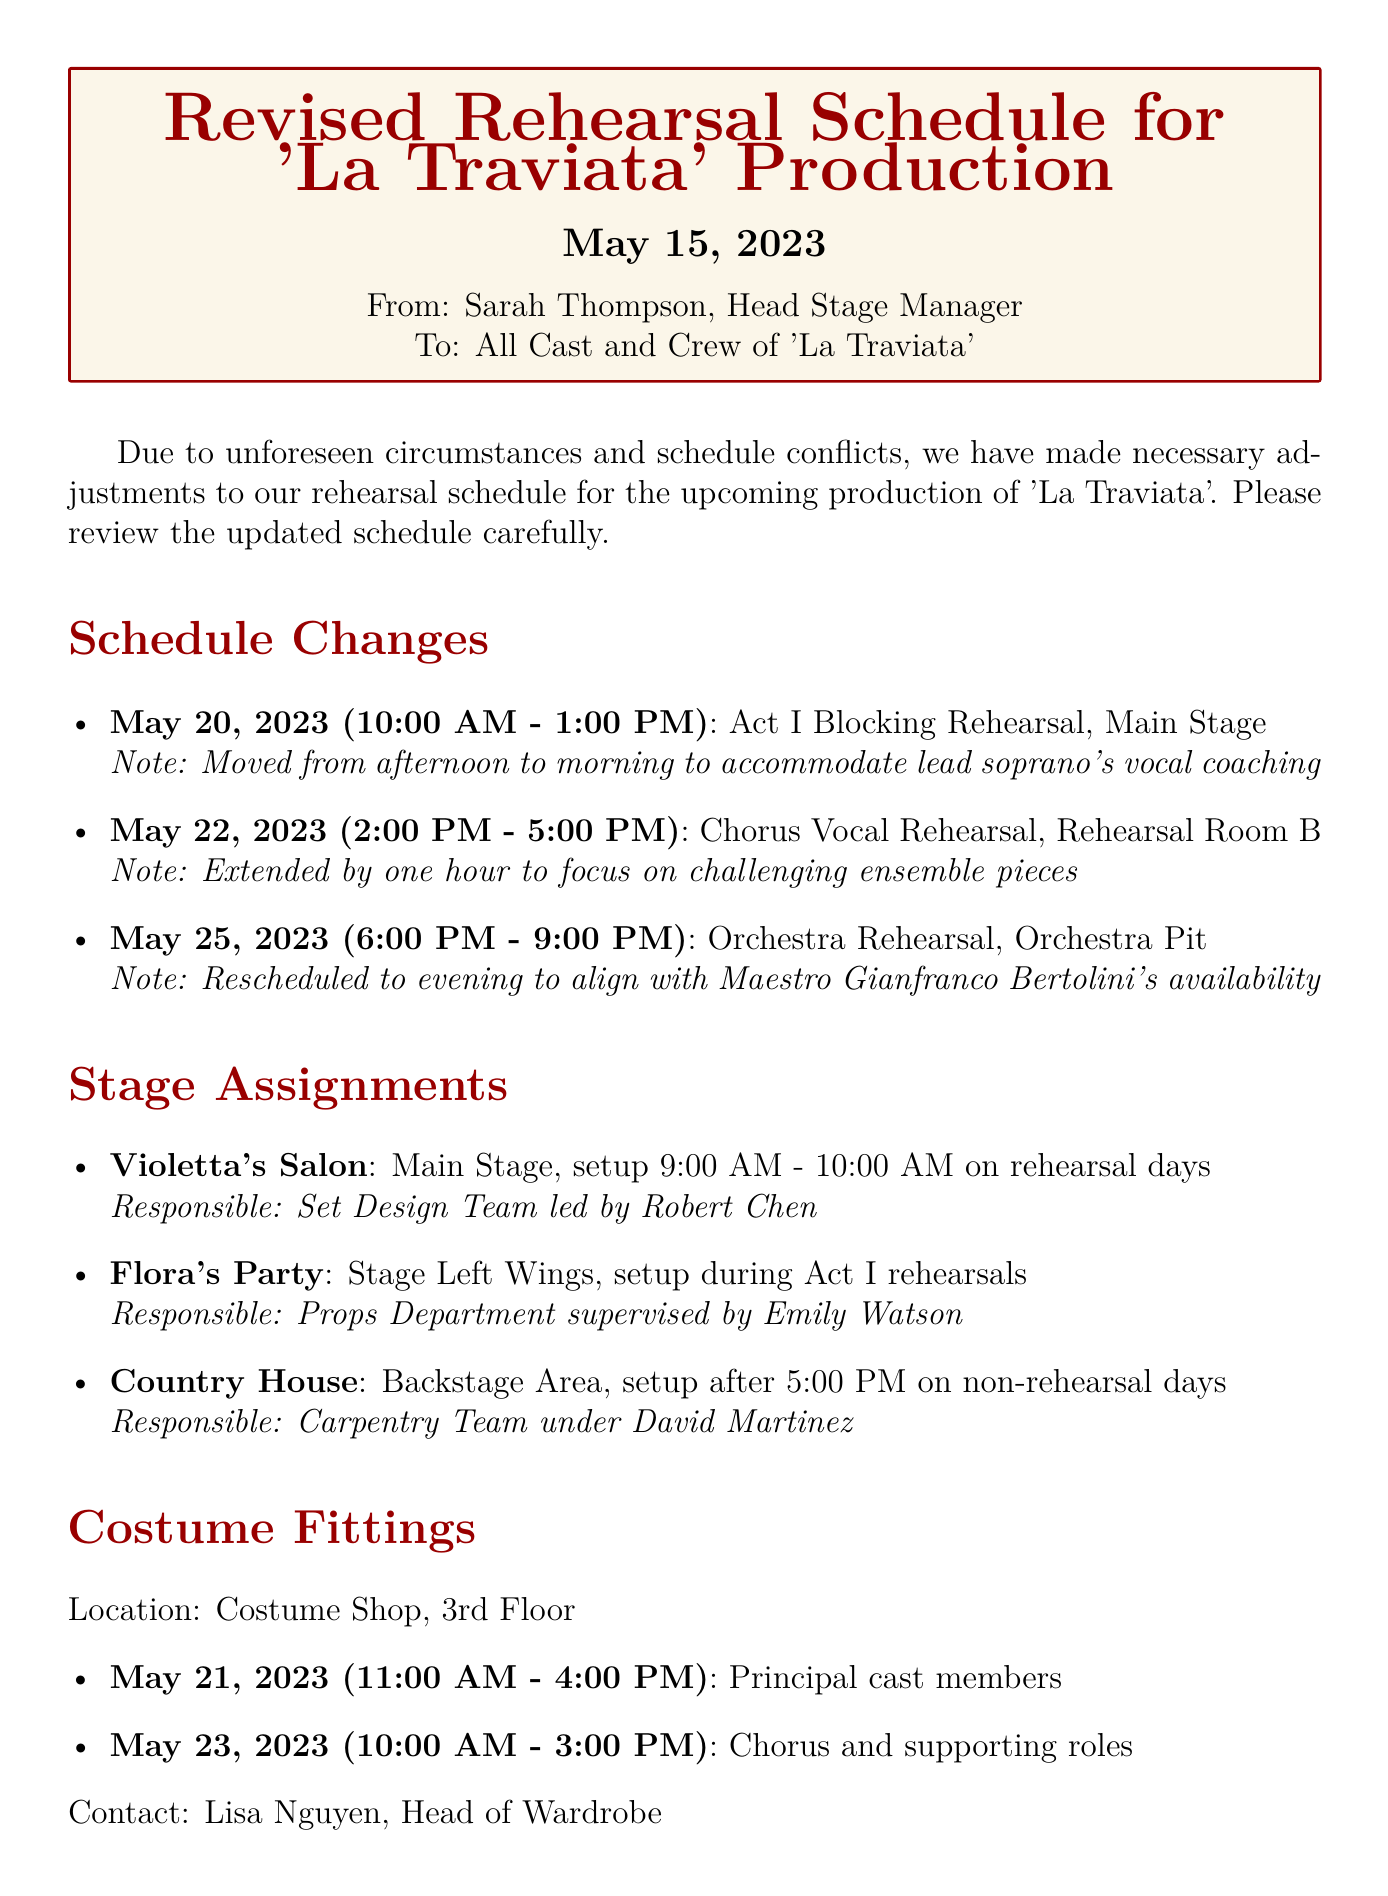What is the date of the revised rehearsal schedule? The date appears at the beginning of the memo, specified as May 15, 2023.
Answer: May 15, 2023 Who is the sender of the memo? The sender is mentioned in the "From" line of the memo, identifying her as Sarah Thompson, Head Stage Manager.
Answer: Sarah Thompson What is the first scheduled rehearsal activity? The first activity is listed under schedule changes, which is Act I Blocking Rehearsal.
Answer: Act I Blocking Rehearsal What is the contact person for costume fittings? The contact for the costume fittings is specified at the end of the costume fittings section.
Answer: Lisa Nguyen How long is the Orchestra Rehearsal scheduled for? The duration of the Orchestra Rehearsal is described in the memo as taking place from 6:00 PM to 9:00 PM.
Answer: 3 hours Which scene is assigned to the Props Department? The scene assigned to the Props Department is detailed in the stage assignments section.
Answer: Flora's Party What time should cast members arrive for warm-ups? The memo states that all cast members must arrive 15 minutes before their scheduled rehearsal time.
Answer: 15 minutes What health protocol is still in effect? A specific health protocol related to COVID is mentioned, which involves daily temperature checks and mask-wearing.
Answer: Daily temperature checks and mask-wearing 